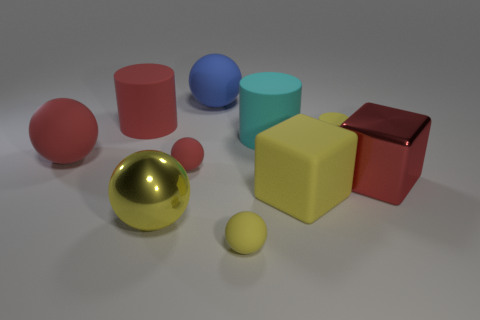Subtract all red matte cylinders. How many cylinders are left? 2 Subtract all cyan cylinders. How many cylinders are left? 2 Subtract all cubes. How many objects are left? 8 Subtract 0 green spheres. How many objects are left? 10 Subtract 2 cylinders. How many cylinders are left? 1 Subtract all green cylinders. Subtract all red blocks. How many cylinders are left? 3 Subtract all gray balls. How many gray cylinders are left? 0 Subtract all big cyan cylinders. Subtract all balls. How many objects are left? 4 Add 6 cyan rubber cylinders. How many cyan rubber cylinders are left? 7 Add 1 gray cubes. How many gray cubes exist? 1 